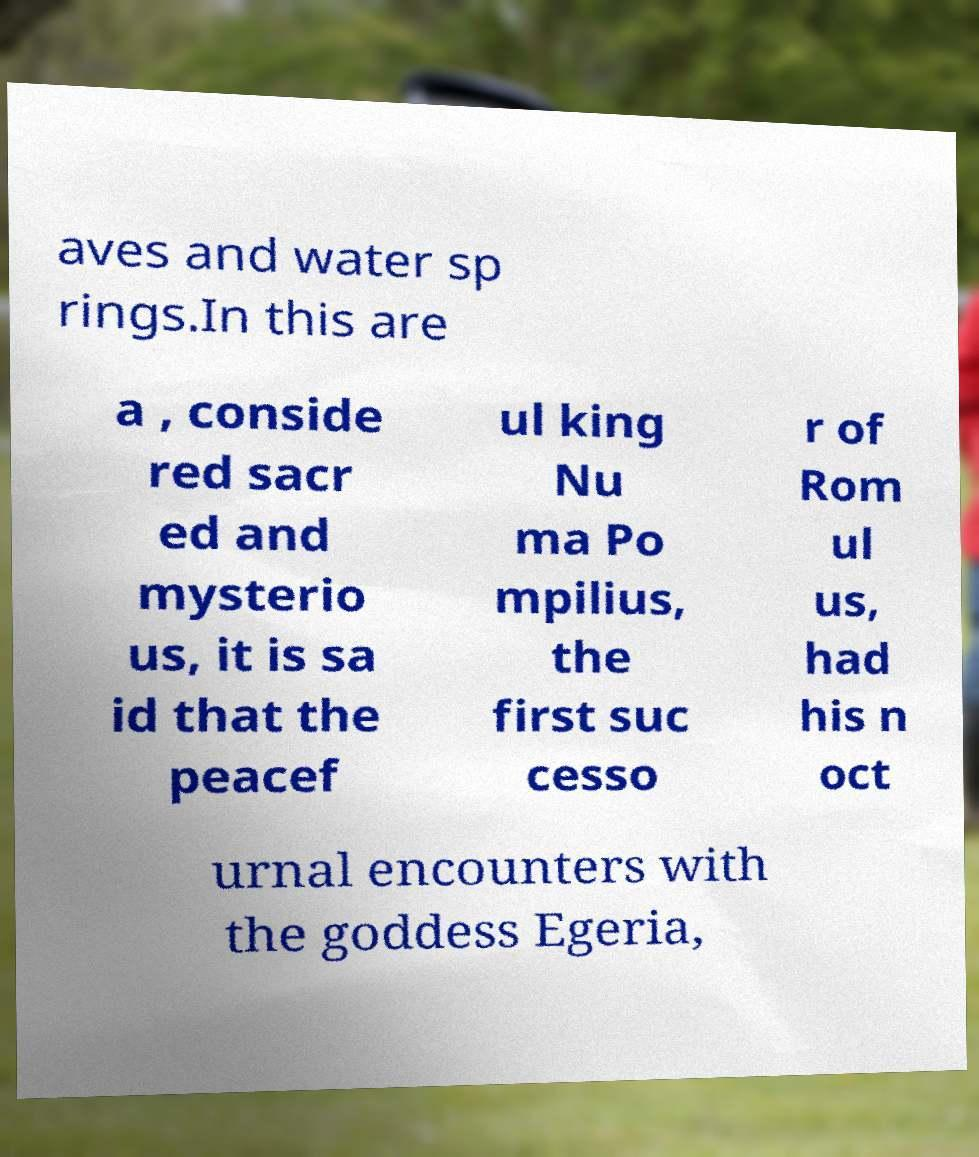For documentation purposes, I need the text within this image transcribed. Could you provide that? aves and water sp rings.In this are a , conside red sacr ed and mysterio us, it is sa id that the peacef ul king Nu ma Po mpilius, the first suc cesso r of Rom ul us, had his n oct urnal encounters with the goddess Egeria, 